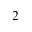Convert formula to latex. <formula><loc_0><loc_0><loc_500><loc_500>_ { 2 }</formula> 